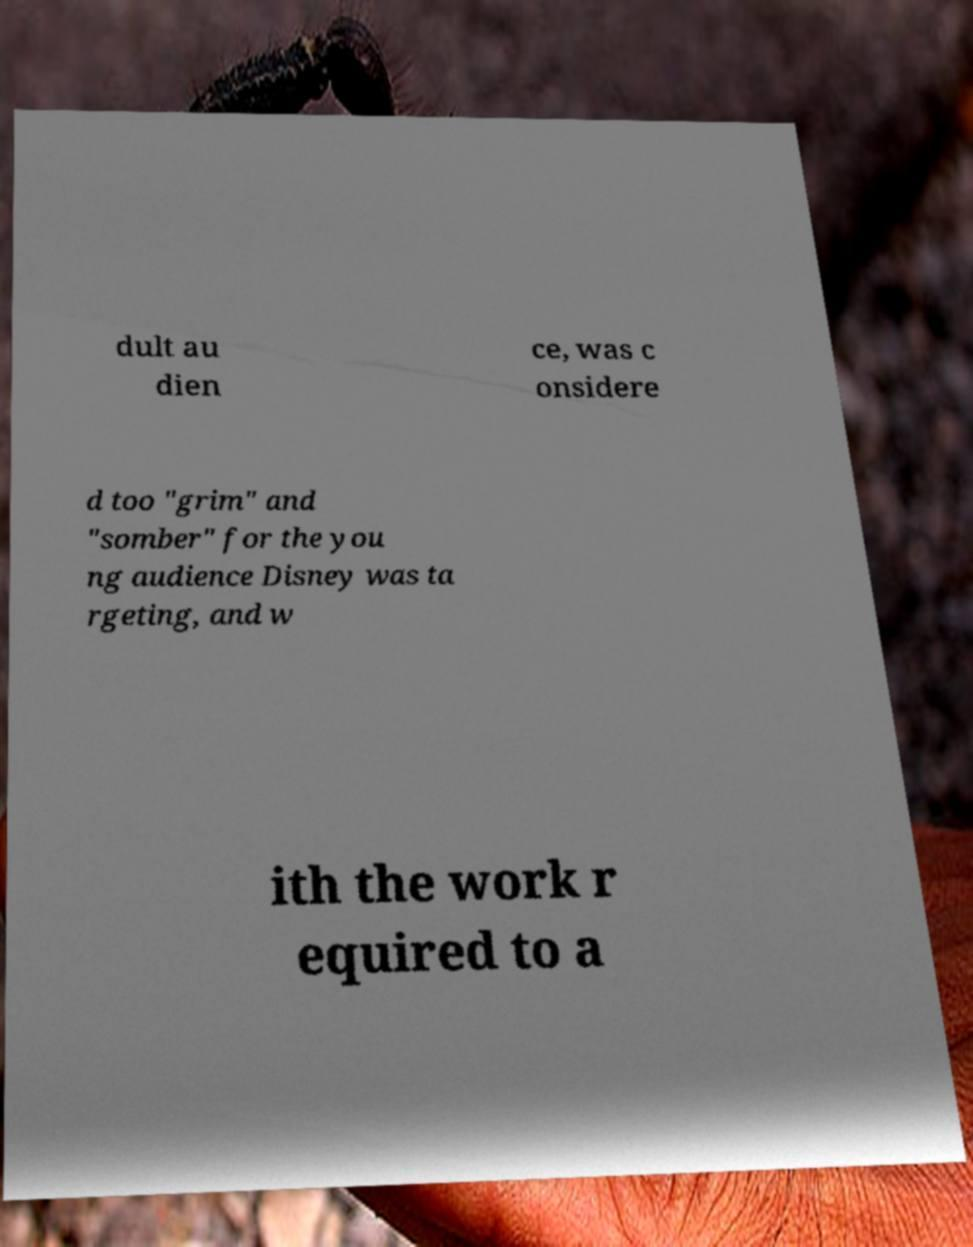There's text embedded in this image that I need extracted. Can you transcribe it verbatim? dult au dien ce, was c onsidere d too "grim" and "somber" for the you ng audience Disney was ta rgeting, and w ith the work r equired to a 